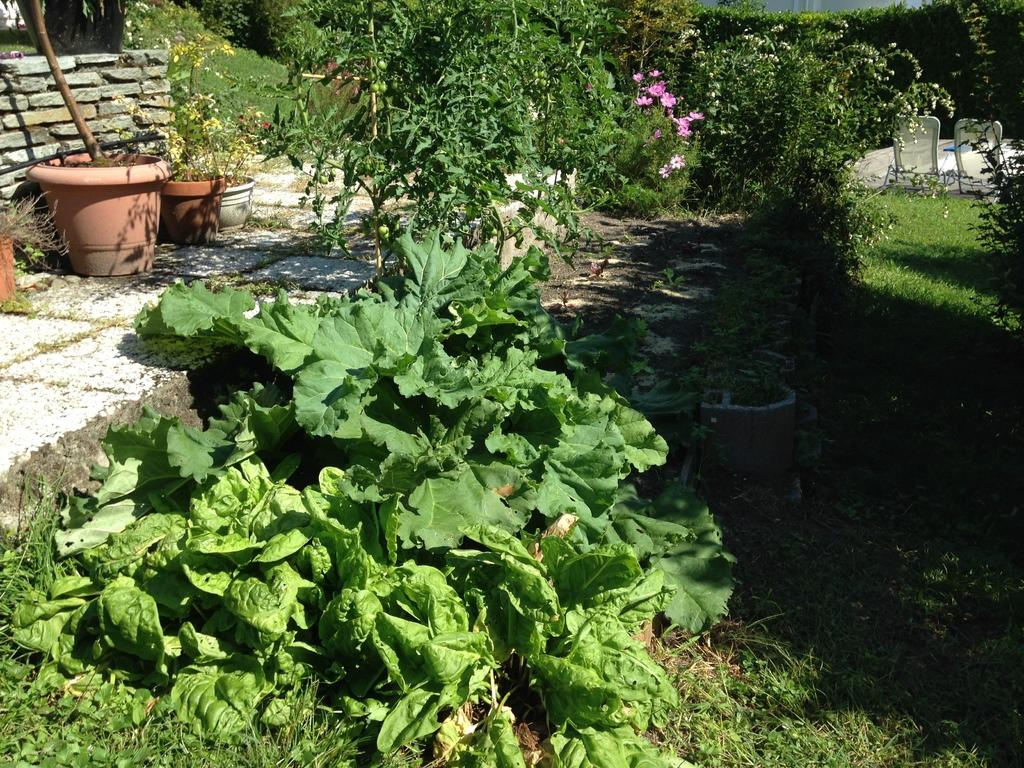What type of vegetation can be seen in the image? There are trees, plants, and grass visible in the image. Where are the potted plants located in the image? The potted plants are on the left side of the image. What is the wall made of in the image? The wall is made of rocks in the image. How many chickens are sitting on the seed in the image? There are no chickens or seeds present in the image. What type of quiver is visible on the wall in the image? There is no quiver visible on the wall in the image. 